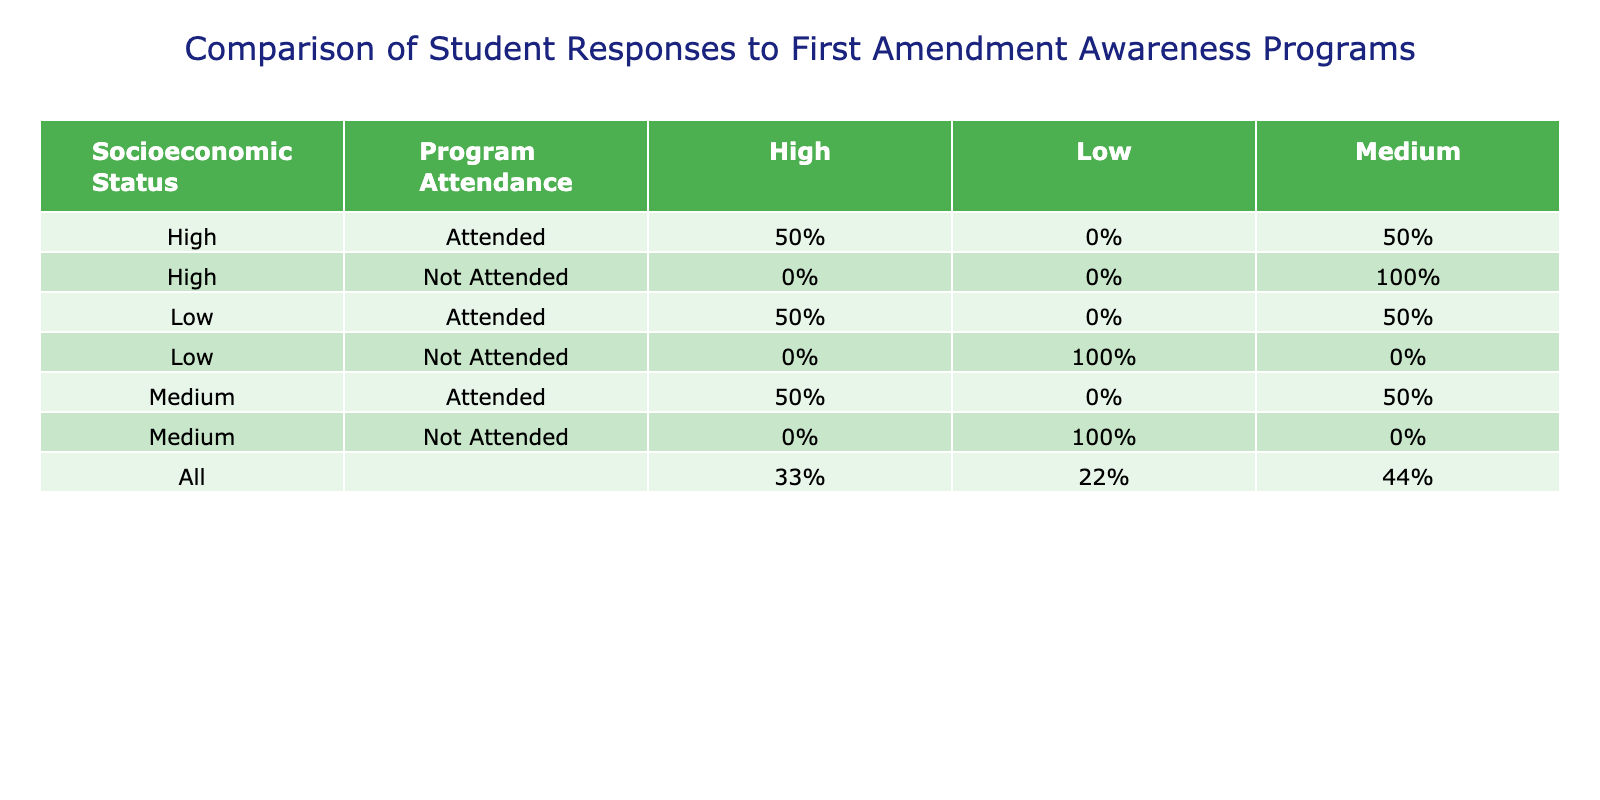What percentage of low socioeconomic status students attended the program? There are three low socioeconomic students, two of whom attended the program. The percentage is (2/3) * 100 = 66.67%.
Answer: 66.67% How many students from high socioeconomic status attended the program with high awareness? There are three high socioeconomic status students, two of whom attended the program and reported high awareness.
Answer: 2 Did any students from medium socioeconomic status report low awareness after attending the program? Looking at the medium socioeconomic students, none of the attended students reported low awareness; all attended students reported high or medium awareness.
Answer: No What is the difference in the percentage of students with high awareness between low and high socioeconomic status? The percentage of high awareness in low socioeconomic status students is 0% (none reported) versus 66.67% in high socioeconomic status. Therefore, the difference is 66.67% - 0% = 66.67%.
Answer: 66.67% In total, how many students were surveyed for the high socioeconomic status category? There were three entries for high socioeconomic status: two attended and one did not attend. Therefore, the total number is 3.
Answer: 3 What is the proportion of students who attended the program and reported medium awareness across all socioeconomic statuses? There are four students who attended and reported medium awareness: two low, one medium, and one high. With a total of six students who attended the program, the proportion is (4/6) = 66.67%.
Answer: 66.67% Is it true that every student who attended the program from low socioeconomic status had high awareness? In the low socioeconomic status category, two students reported high awareness after attending the program, but one student did not attend, which does not affect those who attended.
Answer: Yes How many more students from high socioeconomic status attended the program with high awareness compared to those from medium socioeconomic status? In high socioeconomic status, there are two students with high awareness, and in medium socioeconomic status, there is one. Thus the difference is 2 - 1 = 1 more student.
Answer: 1 